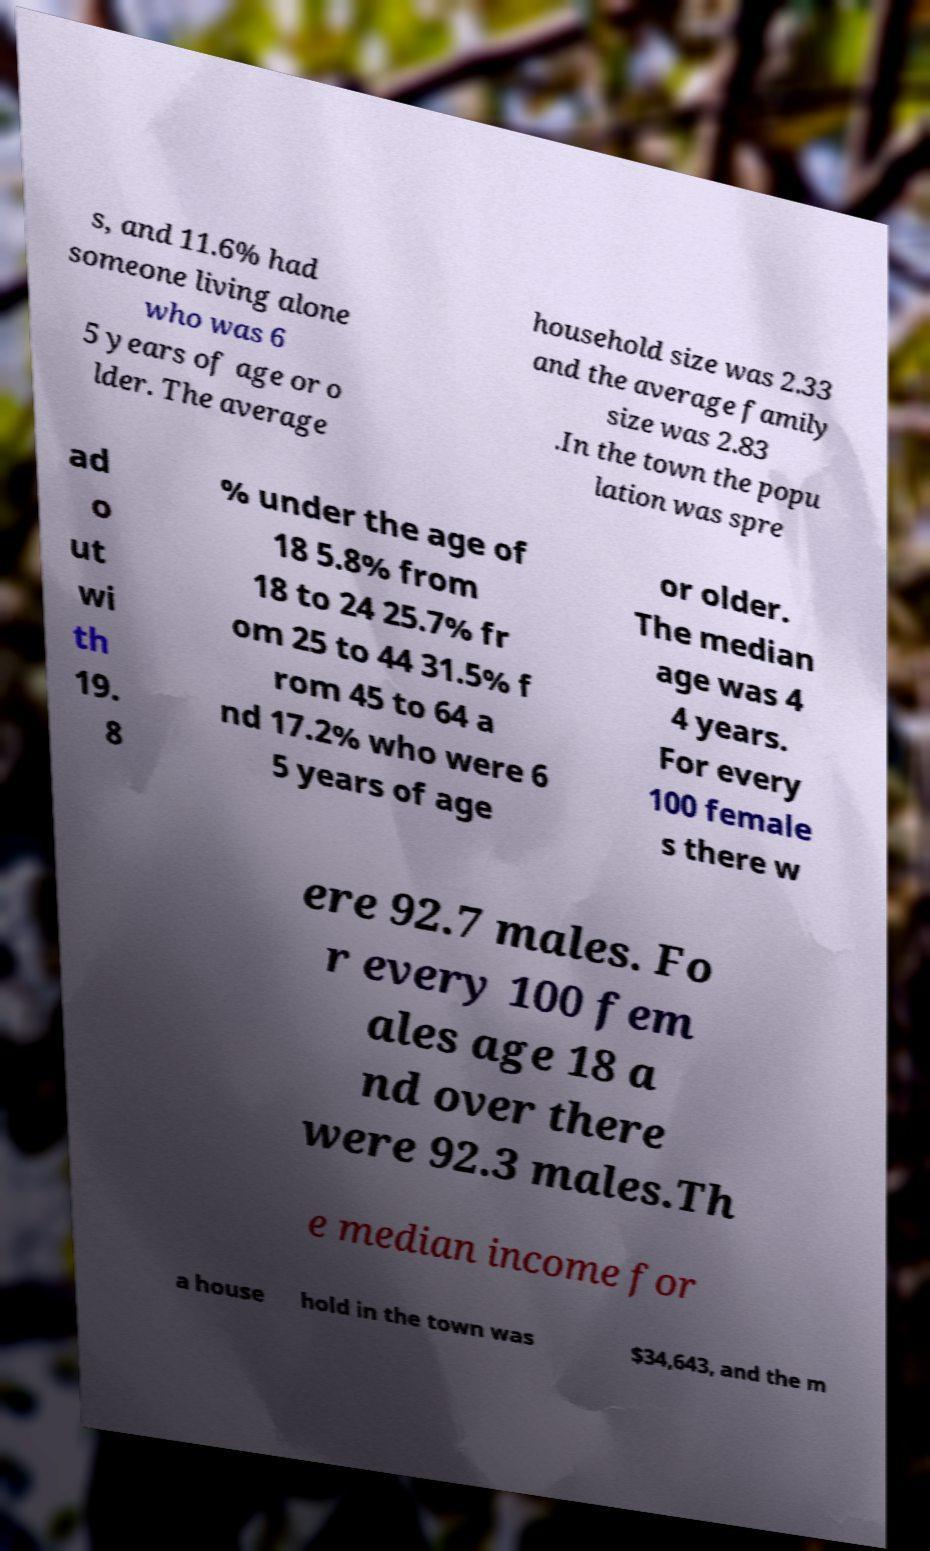Can you read and provide the text displayed in the image?This photo seems to have some interesting text. Can you extract and type it out for me? s, and 11.6% had someone living alone who was 6 5 years of age or o lder. The average household size was 2.33 and the average family size was 2.83 .In the town the popu lation was spre ad o ut wi th 19. 8 % under the age of 18 5.8% from 18 to 24 25.7% fr om 25 to 44 31.5% f rom 45 to 64 a nd 17.2% who were 6 5 years of age or older. The median age was 4 4 years. For every 100 female s there w ere 92.7 males. Fo r every 100 fem ales age 18 a nd over there were 92.3 males.Th e median income for a house hold in the town was $34,643, and the m 